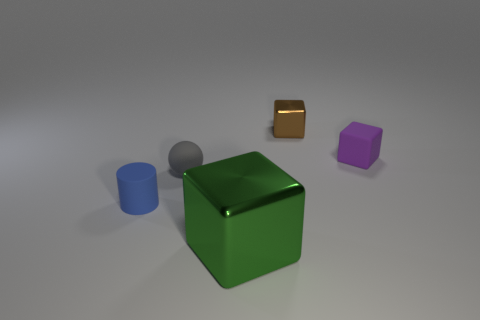Are there any other things that are the same size as the green thing?
Ensure brevity in your answer.  No. What number of objects are both in front of the brown metal object and behind the gray thing?
Offer a terse response. 1. What is the size of the green object that is the same shape as the small purple thing?
Offer a terse response. Large. What number of gray balls are in front of the metallic object that is on the right side of the object in front of the blue rubber cylinder?
Ensure brevity in your answer.  1. There is a metallic cube that is behind the thing that is in front of the small blue rubber object; what color is it?
Keep it short and to the point. Brown. What number of other things are there of the same material as the green cube
Offer a terse response. 1. There is a matte sphere to the left of the green block; what number of matte balls are behind it?
Provide a succinct answer. 0. Are there any other things that are the same shape as the brown metallic object?
Offer a terse response. Yes. There is a metallic object behind the green thing; is it the same color as the metallic block that is in front of the purple block?
Make the answer very short. No. Is the number of cylinders less than the number of small objects?
Make the answer very short. Yes. 